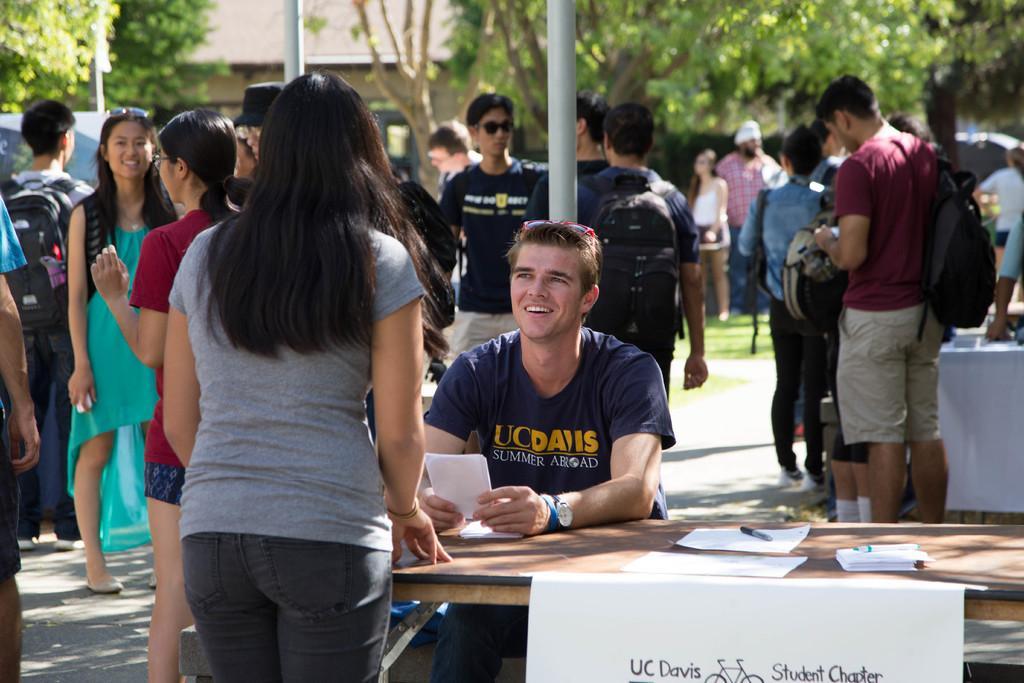In one or two sentences, can you explain what this image depicts? In this picture it's a sunny day. A blue shirt guy is sitting on the table and UC davis Summer Abroad is written on his shirt. A lady is standing opposite to him. There is a wooden table and a set of paper and pen kept on it , UC Davis Student Chapter label is attached to it. Many people are standing around them. Also there are trees in the background. There is also another table in front of the trees 